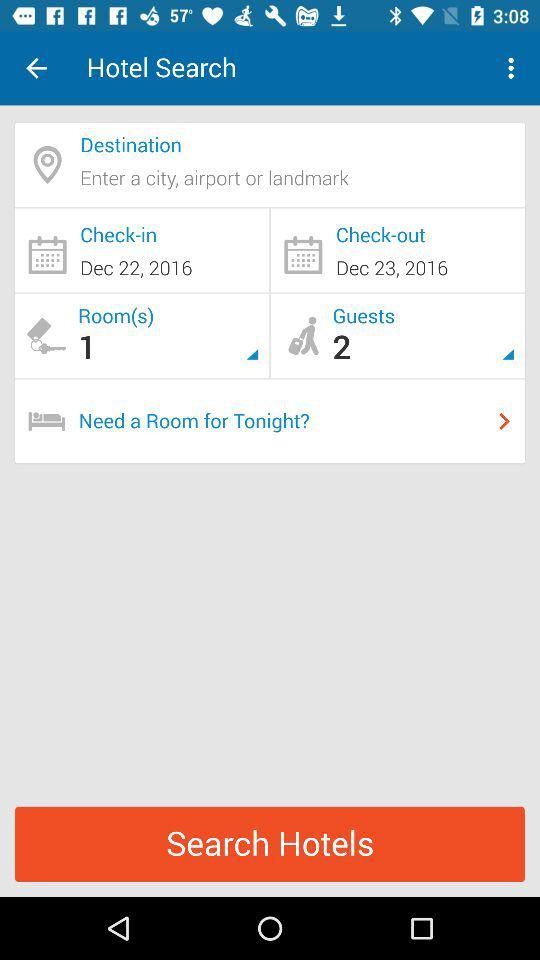Which is the check-out date? The check-out date is December 23, 2016. 